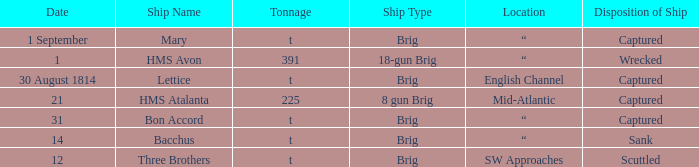Where was the ship when the ship had captured as the disposition of ship and was carrying 225 tonnage? Mid-Atlantic. 